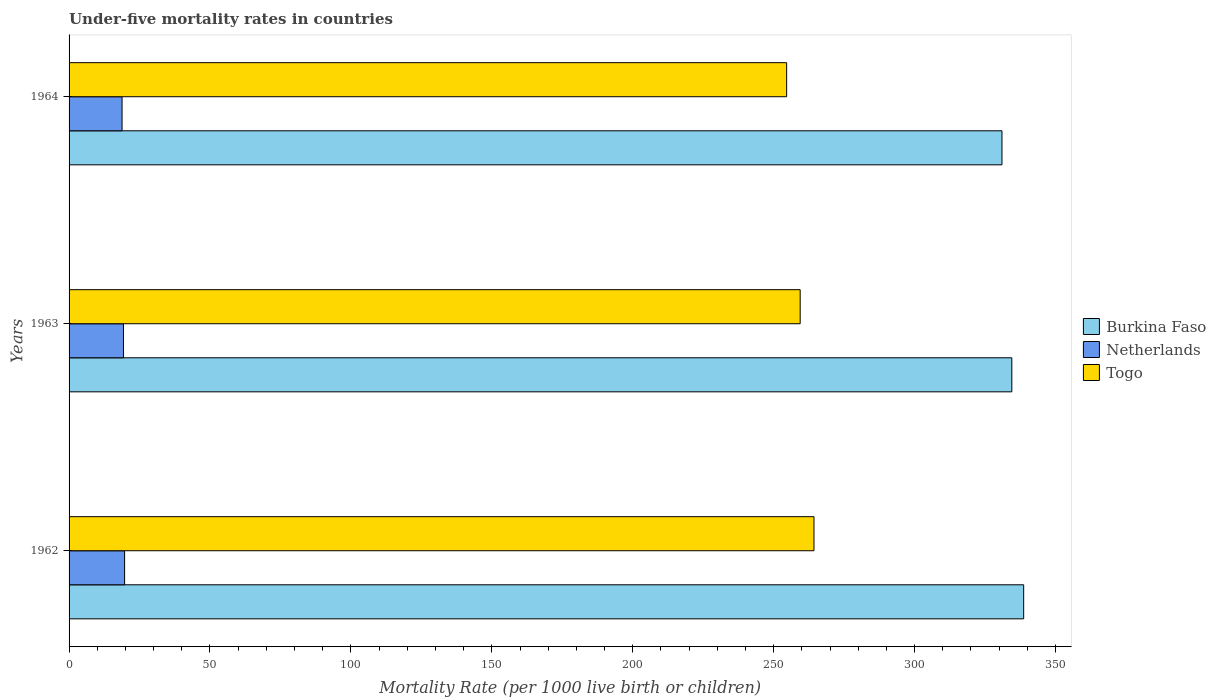Are the number of bars per tick equal to the number of legend labels?
Your answer should be very brief. Yes. Are the number of bars on each tick of the Y-axis equal?
Provide a short and direct response. Yes. How many bars are there on the 1st tick from the top?
Provide a succinct answer. 3. How many bars are there on the 3rd tick from the bottom?
Your answer should be compact. 3. What is the label of the 3rd group of bars from the top?
Provide a succinct answer. 1962. Across all years, what is the maximum under-five mortality rate in Togo?
Your answer should be very brief. 264.3. Across all years, what is the minimum under-five mortality rate in Burkina Faso?
Provide a succinct answer. 331. In which year was the under-five mortality rate in Burkina Faso maximum?
Ensure brevity in your answer.  1962. In which year was the under-five mortality rate in Togo minimum?
Provide a succinct answer. 1964. What is the total under-five mortality rate in Netherlands in the graph?
Keep it short and to the point. 57.8. What is the difference between the under-five mortality rate in Togo in 1963 and that in 1964?
Ensure brevity in your answer.  4.8. What is the difference between the under-five mortality rate in Togo in 1962 and the under-five mortality rate in Netherlands in 1963?
Your response must be concise. 245. What is the average under-five mortality rate in Netherlands per year?
Your answer should be very brief. 19.27. In the year 1964, what is the difference between the under-five mortality rate in Netherlands and under-five mortality rate in Burkina Faso?
Provide a short and direct response. -312.2. In how many years, is the under-five mortality rate in Netherlands greater than 330 ?
Give a very brief answer. 0. What is the ratio of the under-five mortality rate in Togo in 1962 to that in 1963?
Ensure brevity in your answer.  1.02. What is the difference between the highest and the second highest under-five mortality rate in Togo?
Keep it short and to the point. 4.9. What is the difference between the highest and the lowest under-five mortality rate in Burkina Faso?
Ensure brevity in your answer.  7.7. In how many years, is the under-five mortality rate in Netherlands greater than the average under-five mortality rate in Netherlands taken over all years?
Provide a succinct answer. 2. Is the sum of the under-five mortality rate in Netherlands in 1962 and 1963 greater than the maximum under-five mortality rate in Togo across all years?
Offer a very short reply. No. What does the 3rd bar from the top in 1964 represents?
Give a very brief answer. Burkina Faso. What does the 1st bar from the bottom in 1962 represents?
Provide a succinct answer. Burkina Faso. How many bars are there?
Your answer should be compact. 9. Are the values on the major ticks of X-axis written in scientific E-notation?
Offer a very short reply. No. Does the graph contain any zero values?
Your answer should be compact. No. What is the title of the graph?
Offer a very short reply. Under-five mortality rates in countries. What is the label or title of the X-axis?
Offer a very short reply. Mortality Rate (per 1000 live birth or children). What is the label or title of the Y-axis?
Your answer should be compact. Years. What is the Mortality Rate (per 1000 live birth or children) in Burkina Faso in 1962?
Make the answer very short. 338.7. What is the Mortality Rate (per 1000 live birth or children) in Netherlands in 1962?
Offer a very short reply. 19.7. What is the Mortality Rate (per 1000 live birth or children) of Togo in 1962?
Provide a short and direct response. 264.3. What is the Mortality Rate (per 1000 live birth or children) of Burkina Faso in 1963?
Give a very brief answer. 334.5. What is the Mortality Rate (per 1000 live birth or children) in Netherlands in 1963?
Your answer should be very brief. 19.3. What is the Mortality Rate (per 1000 live birth or children) of Togo in 1963?
Your response must be concise. 259.4. What is the Mortality Rate (per 1000 live birth or children) of Burkina Faso in 1964?
Your answer should be compact. 331. What is the Mortality Rate (per 1000 live birth or children) of Togo in 1964?
Provide a short and direct response. 254.6. Across all years, what is the maximum Mortality Rate (per 1000 live birth or children) of Burkina Faso?
Ensure brevity in your answer.  338.7. Across all years, what is the maximum Mortality Rate (per 1000 live birth or children) of Netherlands?
Provide a short and direct response. 19.7. Across all years, what is the maximum Mortality Rate (per 1000 live birth or children) in Togo?
Ensure brevity in your answer.  264.3. Across all years, what is the minimum Mortality Rate (per 1000 live birth or children) in Burkina Faso?
Your answer should be very brief. 331. Across all years, what is the minimum Mortality Rate (per 1000 live birth or children) of Netherlands?
Ensure brevity in your answer.  18.8. Across all years, what is the minimum Mortality Rate (per 1000 live birth or children) in Togo?
Make the answer very short. 254.6. What is the total Mortality Rate (per 1000 live birth or children) in Burkina Faso in the graph?
Provide a succinct answer. 1004.2. What is the total Mortality Rate (per 1000 live birth or children) in Netherlands in the graph?
Offer a very short reply. 57.8. What is the total Mortality Rate (per 1000 live birth or children) in Togo in the graph?
Give a very brief answer. 778.3. What is the difference between the Mortality Rate (per 1000 live birth or children) in Burkina Faso in 1962 and that in 1963?
Give a very brief answer. 4.2. What is the difference between the Mortality Rate (per 1000 live birth or children) in Netherlands in 1962 and that in 1963?
Offer a terse response. 0.4. What is the difference between the Mortality Rate (per 1000 live birth or children) in Burkina Faso in 1963 and that in 1964?
Ensure brevity in your answer.  3.5. What is the difference between the Mortality Rate (per 1000 live birth or children) of Togo in 1963 and that in 1964?
Provide a short and direct response. 4.8. What is the difference between the Mortality Rate (per 1000 live birth or children) in Burkina Faso in 1962 and the Mortality Rate (per 1000 live birth or children) in Netherlands in 1963?
Provide a short and direct response. 319.4. What is the difference between the Mortality Rate (per 1000 live birth or children) of Burkina Faso in 1962 and the Mortality Rate (per 1000 live birth or children) of Togo in 1963?
Ensure brevity in your answer.  79.3. What is the difference between the Mortality Rate (per 1000 live birth or children) in Netherlands in 1962 and the Mortality Rate (per 1000 live birth or children) in Togo in 1963?
Keep it short and to the point. -239.7. What is the difference between the Mortality Rate (per 1000 live birth or children) of Burkina Faso in 1962 and the Mortality Rate (per 1000 live birth or children) of Netherlands in 1964?
Ensure brevity in your answer.  319.9. What is the difference between the Mortality Rate (per 1000 live birth or children) in Burkina Faso in 1962 and the Mortality Rate (per 1000 live birth or children) in Togo in 1964?
Give a very brief answer. 84.1. What is the difference between the Mortality Rate (per 1000 live birth or children) in Netherlands in 1962 and the Mortality Rate (per 1000 live birth or children) in Togo in 1964?
Your answer should be compact. -234.9. What is the difference between the Mortality Rate (per 1000 live birth or children) in Burkina Faso in 1963 and the Mortality Rate (per 1000 live birth or children) in Netherlands in 1964?
Your answer should be compact. 315.7. What is the difference between the Mortality Rate (per 1000 live birth or children) in Burkina Faso in 1963 and the Mortality Rate (per 1000 live birth or children) in Togo in 1964?
Make the answer very short. 79.9. What is the difference between the Mortality Rate (per 1000 live birth or children) of Netherlands in 1963 and the Mortality Rate (per 1000 live birth or children) of Togo in 1964?
Make the answer very short. -235.3. What is the average Mortality Rate (per 1000 live birth or children) in Burkina Faso per year?
Make the answer very short. 334.73. What is the average Mortality Rate (per 1000 live birth or children) in Netherlands per year?
Offer a very short reply. 19.27. What is the average Mortality Rate (per 1000 live birth or children) in Togo per year?
Your answer should be very brief. 259.43. In the year 1962, what is the difference between the Mortality Rate (per 1000 live birth or children) in Burkina Faso and Mortality Rate (per 1000 live birth or children) in Netherlands?
Provide a short and direct response. 319. In the year 1962, what is the difference between the Mortality Rate (per 1000 live birth or children) of Burkina Faso and Mortality Rate (per 1000 live birth or children) of Togo?
Your answer should be compact. 74.4. In the year 1962, what is the difference between the Mortality Rate (per 1000 live birth or children) in Netherlands and Mortality Rate (per 1000 live birth or children) in Togo?
Give a very brief answer. -244.6. In the year 1963, what is the difference between the Mortality Rate (per 1000 live birth or children) of Burkina Faso and Mortality Rate (per 1000 live birth or children) of Netherlands?
Provide a succinct answer. 315.2. In the year 1963, what is the difference between the Mortality Rate (per 1000 live birth or children) of Burkina Faso and Mortality Rate (per 1000 live birth or children) of Togo?
Give a very brief answer. 75.1. In the year 1963, what is the difference between the Mortality Rate (per 1000 live birth or children) of Netherlands and Mortality Rate (per 1000 live birth or children) of Togo?
Your response must be concise. -240.1. In the year 1964, what is the difference between the Mortality Rate (per 1000 live birth or children) of Burkina Faso and Mortality Rate (per 1000 live birth or children) of Netherlands?
Offer a very short reply. 312.2. In the year 1964, what is the difference between the Mortality Rate (per 1000 live birth or children) of Burkina Faso and Mortality Rate (per 1000 live birth or children) of Togo?
Give a very brief answer. 76.4. In the year 1964, what is the difference between the Mortality Rate (per 1000 live birth or children) of Netherlands and Mortality Rate (per 1000 live birth or children) of Togo?
Make the answer very short. -235.8. What is the ratio of the Mortality Rate (per 1000 live birth or children) in Burkina Faso in 1962 to that in 1963?
Your answer should be very brief. 1.01. What is the ratio of the Mortality Rate (per 1000 live birth or children) in Netherlands in 1962 to that in 1963?
Your answer should be compact. 1.02. What is the ratio of the Mortality Rate (per 1000 live birth or children) in Togo in 1962 to that in 1963?
Make the answer very short. 1.02. What is the ratio of the Mortality Rate (per 1000 live birth or children) of Burkina Faso in 1962 to that in 1964?
Offer a very short reply. 1.02. What is the ratio of the Mortality Rate (per 1000 live birth or children) of Netherlands in 1962 to that in 1964?
Your response must be concise. 1.05. What is the ratio of the Mortality Rate (per 1000 live birth or children) in Togo in 1962 to that in 1964?
Your answer should be very brief. 1.04. What is the ratio of the Mortality Rate (per 1000 live birth or children) in Burkina Faso in 1963 to that in 1964?
Offer a very short reply. 1.01. What is the ratio of the Mortality Rate (per 1000 live birth or children) in Netherlands in 1963 to that in 1964?
Provide a succinct answer. 1.03. What is the ratio of the Mortality Rate (per 1000 live birth or children) in Togo in 1963 to that in 1964?
Provide a succinct answer. 1.02. 